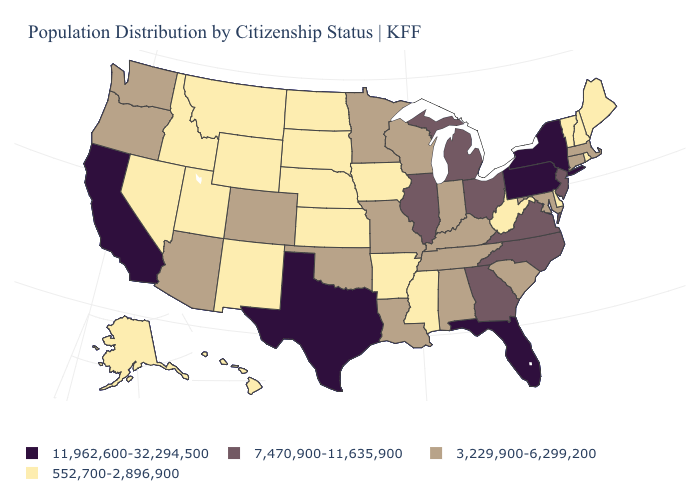Among the states that border Delaware , which have the lowest value?
Keep it brief. Maryland. Name the states that have a value in the range 11,962,600-32,294,500?
Write a very short answer. California, Florida, New York, Pennsylvania, Texas. Name the states that have a value in the range 552,700-2,896,900?
Answer briefly. Alaska, Arkansas, Delaware, Hawaii, Idaho, Iowa, Kansas, Maine, Mississippi, Montana, Nebraska, Nevada, New Hampshire, New Mexico, North Dakota, Rhode Island, South Dakota, Utah, Vermont, West Virginia, Wyoming. What is the value of North Dakota?
Give a very brief answer. 552,700-2,896,900. Among the states that border Arkansas , which have the lowest value?
Be succinct. Mississippi. Name the states that have a value in the range 7,470,900-11,635,900?
Keep it brief. Georgia, Illinois, Michigan, New Jersey, North Carolina, Ohio, Virginia. What is the highest value in the USA?
Short answer required. 11,962,600-32,294,500. How many symbols are there in the legend?
Answer briefly. 4. What is the value of Massachusetts?
Concise answer only. 3,229,900-6,299,200. Which states have the lowest value in the MidWest?
Be succinct. Iowa, Kansas, Nebraska, North Dakota, South Dakota. Name the states that have a value in the range 11,962,600-32,294,500?
Write a very short answer. California, Florida, New York, Pennsylvania, Texas. What is the lowest value in states that border Massachusetts?
Keep it brief. 552,700-2,896,900. Is the legend a continuous bar?
Keep it brief. No. What is the value of New Jersey?
Concise answer only. 7,470,900-11,635,900. 